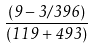<formula> <loc_0><loc_0><loc_500><loc_500>\frac { ( 9 - 3 / 3 9 6 ) } { ( 1 1 9 + 4 9 3 ) }</formula> 